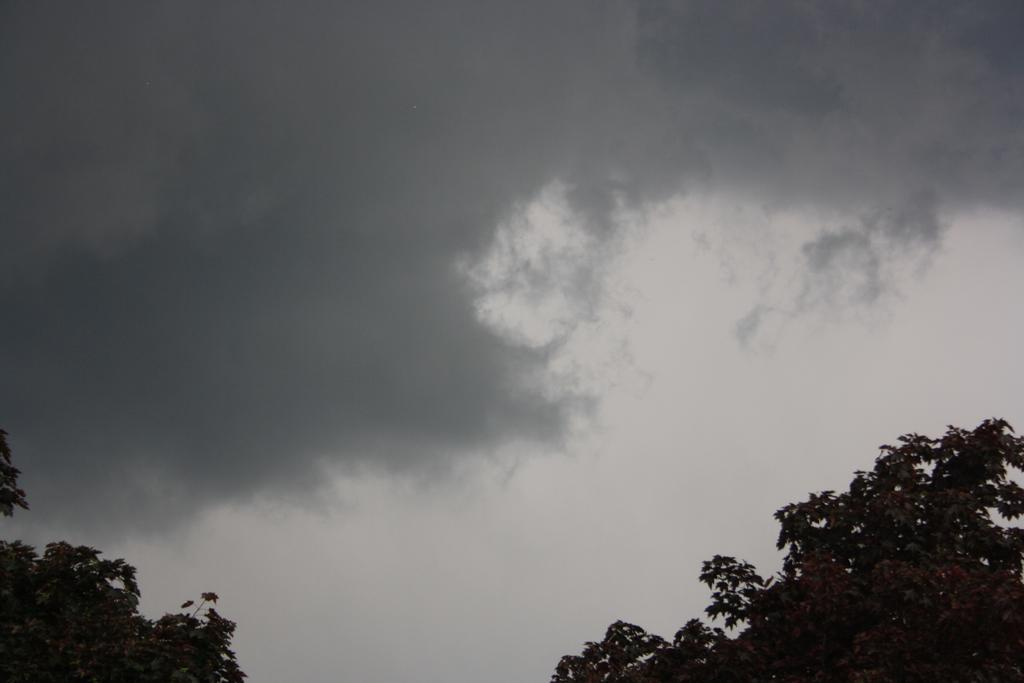Where was the image taken? The image was taken outside. What can be seen at the bottom left of the image? There are trees at the bottom left of the image. What can be seen at the bottom right of the image? There are trees at the bottom right of the image. What is visible at the top of the image? The sky is visible at the top of the image. What can be observed in the sky? Clouds are present in the sky. Where is the spade located in the image? There is no spade present in the image. What type of box can be seen in the image? There is no box present in the image. 